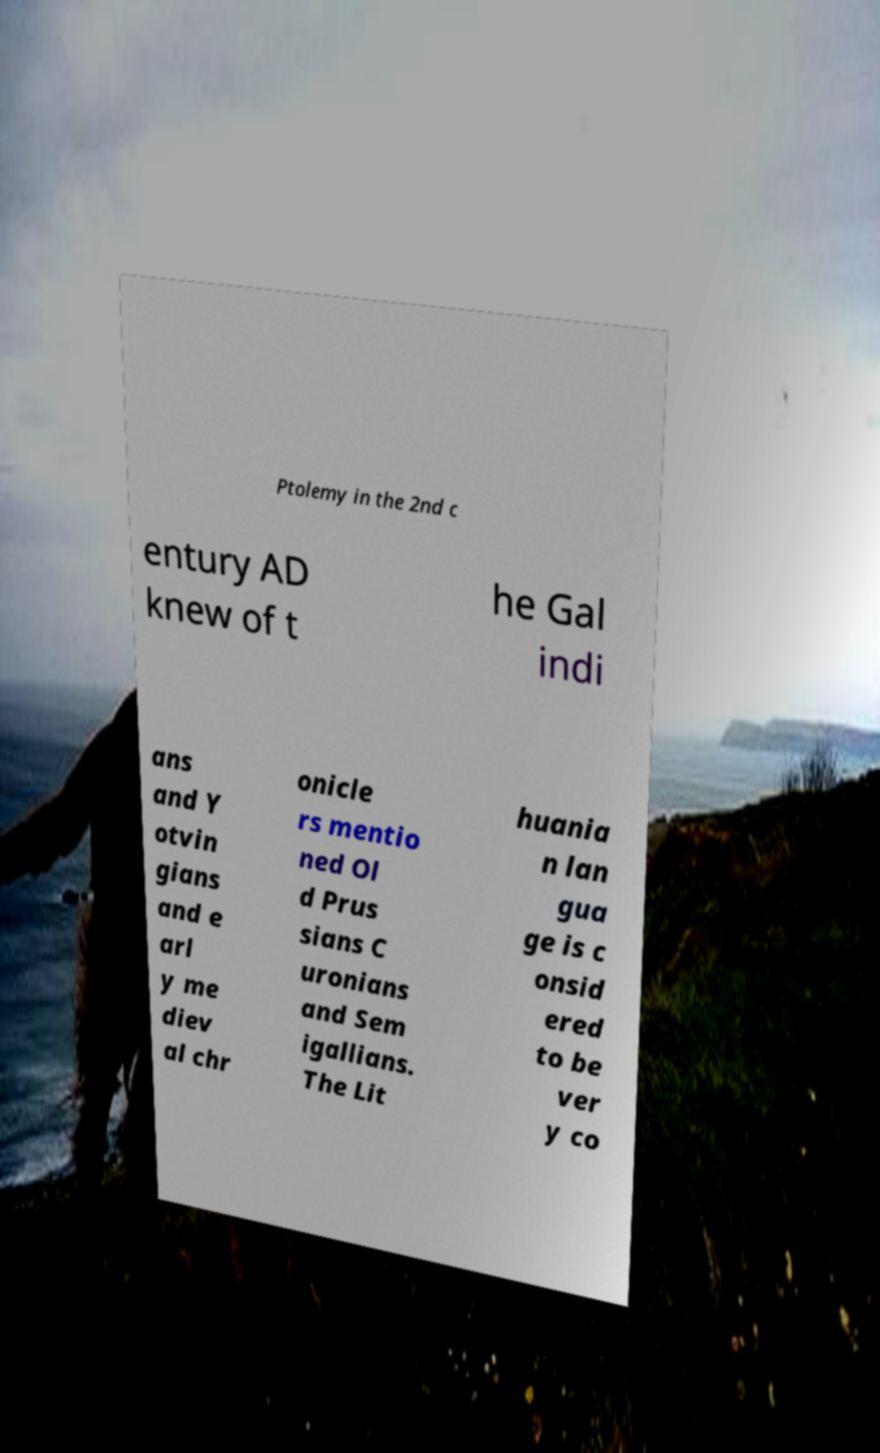There's text embedded in this image that I need extracted. Can you transcribe it verbatim? Ptolemy in the 2nd c entury AD knew of t he Gal indi ans and Y otvin gians and e arl y me diev al chr onicle rs mentio ned Ol d Prus sians C uronians and Sem igallians. The Lit huania n lan gua ge is c onsid ered to be ver y co 